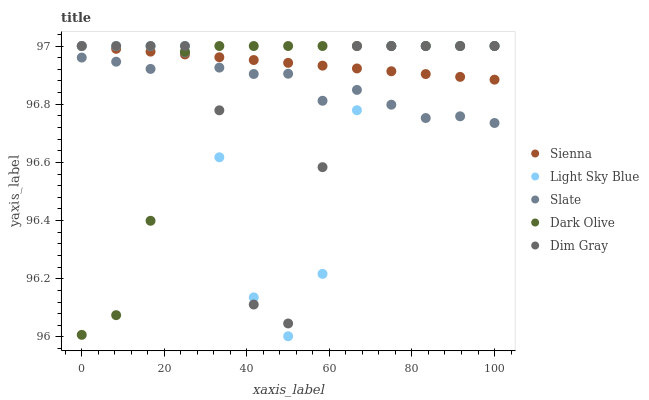Does Light Sky Blue have the minimum area under the curve?
Answer yes or no. Yes. Does Sienna have the maximum area under the curve?
Answer yes or no. Yes. Does Slate have the minimum area under the curve?
Answer yes or no. No. Does Slate have the maximum area under the curve?
Answer yes or no. No. Is Sienna the smoothest?
Answer yes or no. Yes. Is Dim Gray the roughest?
Answer yes or no. Yes. Is Slate the smoothest?
Answer yes or no. No. Is Slate the roughest?
Answer yes or no. No. Does Light Sky Blue have the lowest value?
Answer yes or no. Yes. Does Slate have the lowest value?
Answer yes or no. No. Does Dim Gray have the highest value?
Answer yes or no. Yes. Does Slate have the highest value?
Answer yes or no. No. Does Dark Olive intersect Sienna?
Answer yes or no. Yes. Is Dark Olive less than Sienna?
Answer yes or no. No. Is Dark Olive greater than Sienna?
Answer yes or no. No. 